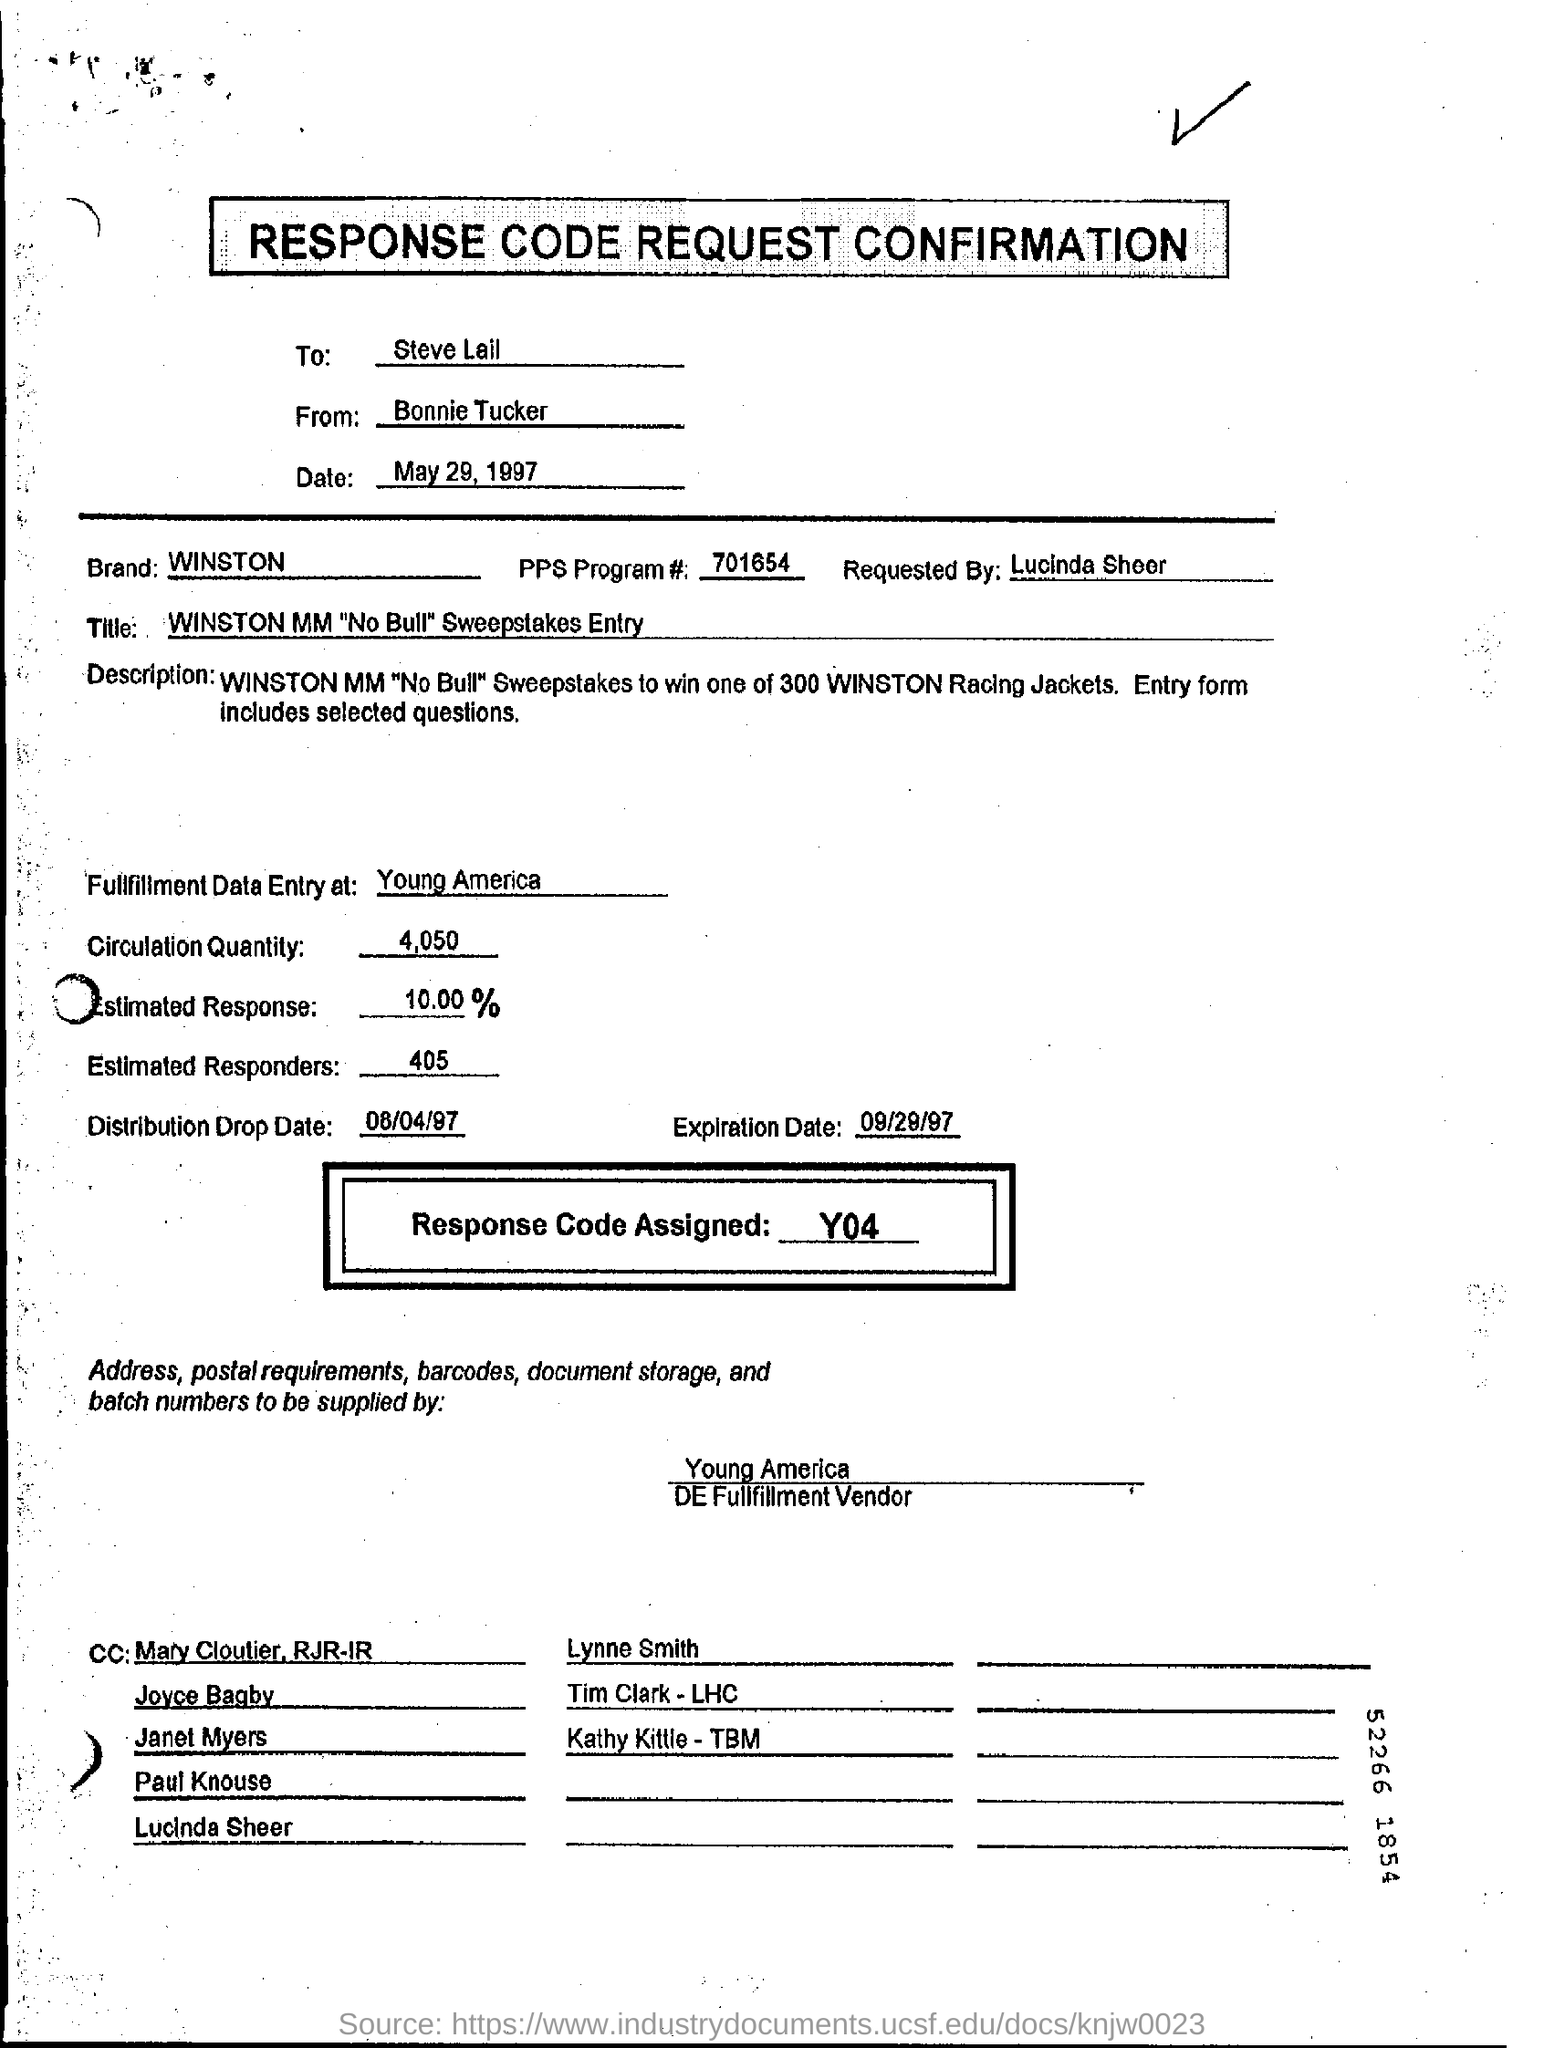To whom is it addressed to?
Provide a succinct answer. Steve Lail. Who is it From?
Offer a terse response. Bonnie Tucker. What is the Date?
Offer a terse response. May 29, 1997. What is the Brand?
Provide a succinct answer. Winston. What is the PPs Program #?
Your answer should be very brief. 701654. Who was it requested by?
Make the answer very short. Lucinda Sheer. Where is the fullfillment data entry at?
Your answer should be very brief. Young America. What is the Circulation Qty?
Ensure brevity in your answer.  4,050. What is the Estimated Response?
Make the answer very short. 10.00 %. What is the Estimated Responders?
Offer a terse response. 405. 